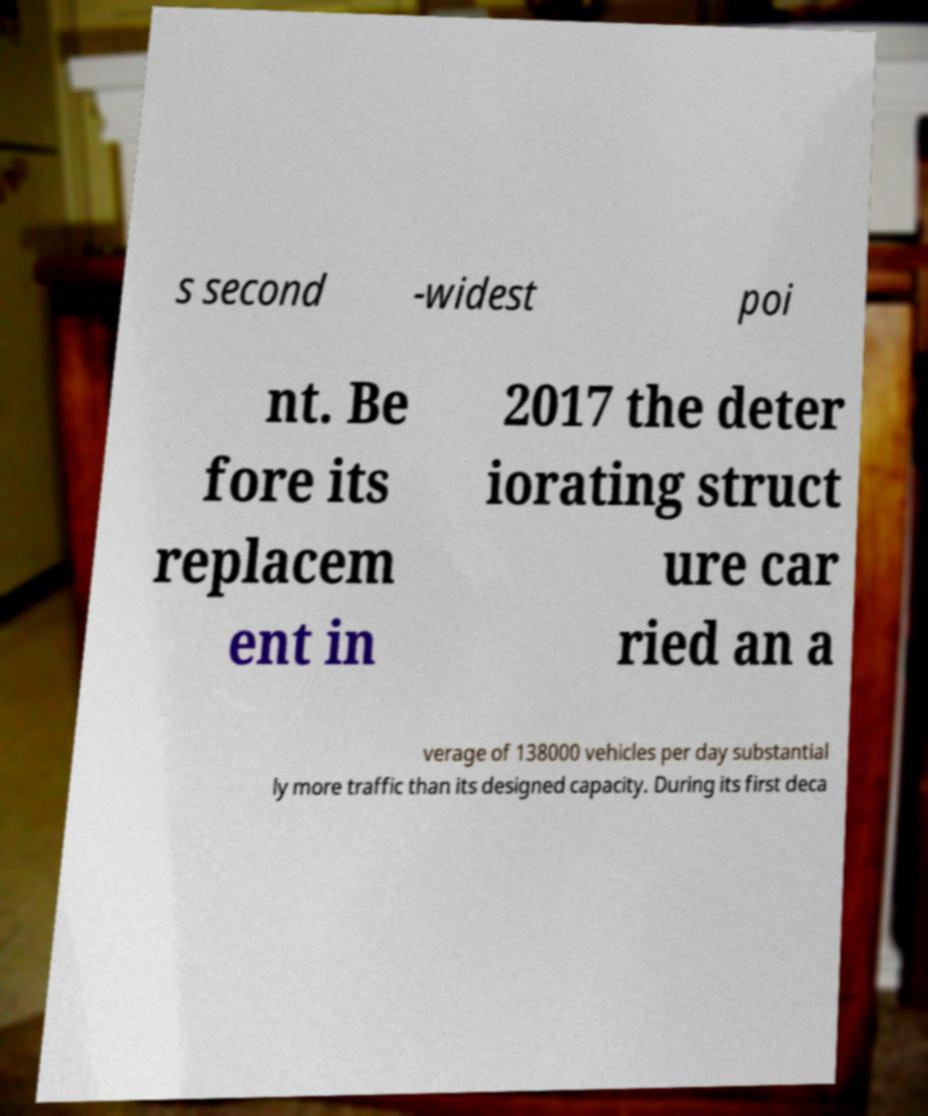Please identify and transcribe the text found in this image. s second -widest poi nt. Be fore its replacem ent in 2017 the deter iorating struct ure car ried an a verage of 138000 vehicles per day substantial ly more traffic than its designed capacity. During its first deca 